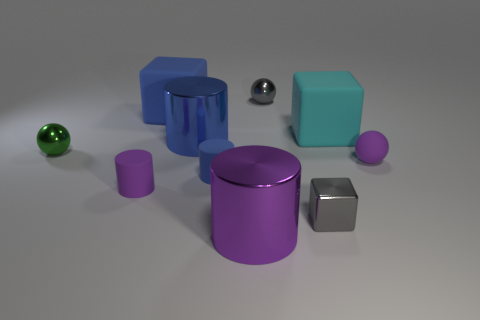What can you say about the colors and materials of the objects? The objects boast a range of hues and finishes. There are matte objects in purple, teal, and grey, while the shiny ones are metallic and reflective, indicating they are made from different materials with various textures. Could these objects be representative of any specific theme or concept? These objects could be used to discuss themes like diversity and variety, as they differ in color, shape, texture, and reflectivity, yet coexist within the same space. 